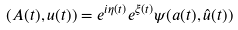<formula> <loc_0><loc_0><loc_500><loc_500>( A ( t ) , u ( t ) ) = e ^ { i \eta ( t ) } e ^ { \xi ( t ) } \psi ( a ( t ) , \hat { u } ( t ) )</formula> 